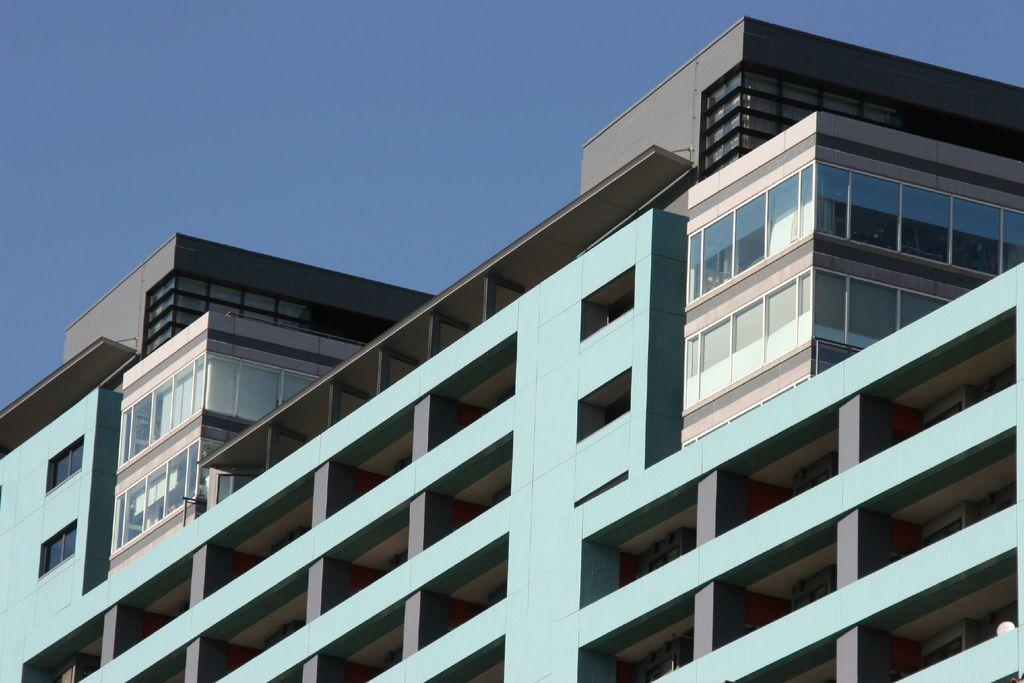What is the main subject in the picture? There is a building in the picture. What can be seen in the background of the picture? The sky is visible in the background of the picture. How many pigs are sitting on the lamp in the picture? There are no pigs or lamps present in the picture. 